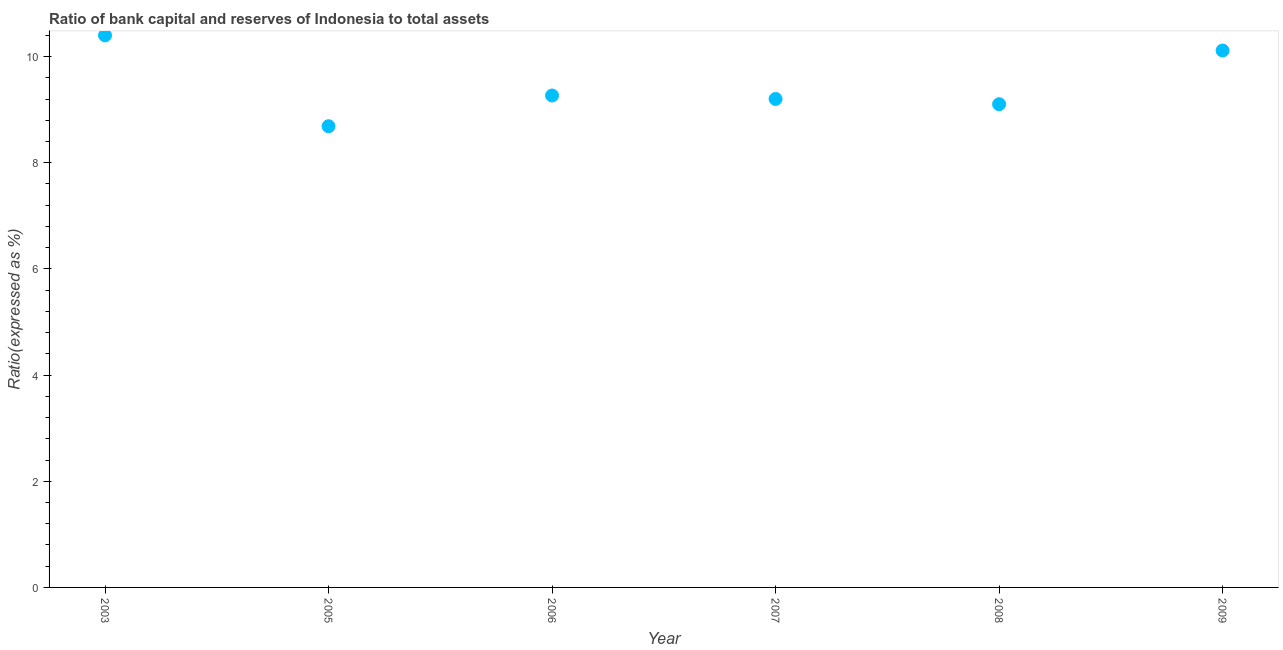What is the bank capital to assets ratio in 2005?
Ensure brevity in your answer.  8.69. Across all years, what is the minimum bank capital to assets ratio?
Provide a short and direct response. 8.69. In which year was the bank capital to assets ratio maximum?
Make the answer very short. 2003. What is the sum of the bank capital to assets ratio?
Offer a terse response. 56.78. What is the difference between the bank capital to assets ratio in 2006 and 2008?
Provide a succinct answer. 0.16. What is the average bank capital to assets ratio per year?
Your answer should be compact. 9.46. What is the median bank capital to assets ratio?
Give a very brief answer. 9.23. In how many years, is the bank capital to assets ratio greater than 3.6 %?
Your response must be concise. 6. Do a majority of the years between 2009 and 2007 (inclusive) have bank capital to assets ratio greater than 2.4 %?
Ensure brevity in your answer.  No. What is the ratio of the bank capital to assets ratio in 2005 to that in 2007?
Provide a short and direct response. 0.94. Is the bank capital to assets ratio in 2003 less than that in 2005?
Ensure brevity in your answer.  No. What is the difference between the highest and the second highest bank capital to assets ratio?
Your answer should be very brief. 0.29. Is the sum of the bank capital to assets ratio in 2006 and 2007 greater than the maximum bank capital to assets ratio across all years?
Your answer should be very brief. Yes. What is the difference between the highest and the lowest bank capital to assets ratio?
Give a very brief answer. 1.71. In how many years, is the bank capital to assets ratio greater than the average bank capital to assets ratio taken over all years?
Your answer should be compact. 2. Does the bank capital to assets ratio monotonically increase over the years?
Your answer should be very brief. No. How many years are there in the graph?
Provide a short and direct response. 6. Does the graph contain any zero values?
Offer a terse response. No. What is the title of the graph?
Your response must be concise. Ratio of bank capital and reserves of Indonesia to total assets. What is the label or title of the X-axis?
Give a very brief answer. Year. What is the label or title of the Y-axis?
Provide a short and direct response. Ratio(expressed as %). What is the Ratio(expressed as %) in 2003?
Your answer should be compact. 10.4. What is the Ratio(expressed as %) in 2005?
Provide a short and direct response. 8.69. What is the Ratio(expressed as %) in 2006?
Make the answer very short. 9.27. What is the Ratio(expressed as %) in 2007?
Your response must be concise. 9.2. What is the Ratio(expressed as %) in 2008?
Offer a very short reply. 9.1. What is the Ratio(expressed as %) in 2009?
Your response must be concise. 10.11. What is the difference between the Ratio(expressed as %) in 2003 and 2005?
Your answer should be very brief. 1.71. What is the difference between the Ratio(expressed as %) in 2003 and 2006?
Offer a terse response. 1.13. What is the difference between the Ratio(expressed as %) in 2003 and 2007?
Give a very brief answer. 1.2. What is the difference between the Ratio(expressed as %) in 2003 and 2008?
Provide a short and direct response. 1.3. What is the difference between the Ratio(expressed as %) in 2003 and 2009?
Your response must be concise. 0.29. What is the difference between the Ratio(expressed as %) in 2005 and 2006?
Your response must be concise. -0.58. What is the difference between the Ratio(expressed as %) in 2005 and 2007?
Your answer should be compact. -0.51. What is the difference between the Ratio(expressed as %) in 2005 and 2008?
Your answer should be compact. -0.41. What is the difference between the Ratio(expressed as %) in 2005 and 2009?
Provide a succinct answer. -1.43. What is the difference between the Ratio(expressed as %) in 2006 and 2007?
Make the answer very short. 0.07. What is the difference between the Ratio(expressed as %) in 2006 and 2008?
Provide a short and direct response. 0.16. What is the difference between the Ratio(expressed as %) in 2006 and 2009?
Your answer should be very brief. -0.85. What is the difference between the Ratio(expressed as %) in 2007 and 2008?
Give a very brief answer. 0.1. What is the difference between the Ratio(expressed as %) in 2007 and 2009?
Ensure brevity in your answer.  -0.91. What is the difference between the Ratio(expressed as %) in 2008 and 2009?
Provide a short and direct response. -1.01. What is the ratio of the Ratio(expressed as %) in 2003 to that in 2005?
Provide a short and direct response. 1.2. What is the ratio of the Ratio(expressed as %) in 2003 to that in 2006?
Offer a very short reply. 1.12. What is the ratio of the Ratio(expressed as %) in 2003 to that in 2007?
Provide a succinct answer. 1.13. What is the ratio of the Ratio(expressed as %) in 2003 to that in 2008?
Your answer should be compact. 1.14. What is the ratio of the Ratio(expressed as %) in 2003 to that in 2009?
Provide a succinct answer. 1.03. What is the ratio of the Ratio(expressed as %) in 2005 to that in 2006?
Your answer should be very brief. 0.94. What is the ratio of the Ratio(expressed as %) in 2005 to that in 2007?
Offer a very short reply. 0.94. What is the ratio of the Ratio(expressed as %) in 2005 to that in 2008?
Your answer should be very brief. 0.95. What is the ratio of the Ratio(expressed as %) in 2005 to that in 2009?
Make the answer very short. 0.86. What is the ratio of the Ratio(expressed as %) in 2006 to that in 2007?
Provide a succinct answer. 1.01. What is the ratio of the Ratio(expressed as %) in 2006 to that in 2008?
Make the answer very short. 1.02. What is the ratio of the Ratio(expressed as %) in 2006 to that in 2009?
Offer a terse response. 0.92. What is the ratio of the Ratio(expressed as %) in 2007 to that in 2008?
Keep it short and to the point. 1.01. What is the ratio of the Ratio(expressed as %) in 2007 to that in 2009?
Give a very brief answer. 0.91. What is the ratio of the Ratio(expressed as %) in 2008 to that in 2009?
Keep it short and to the point. 0.9. 